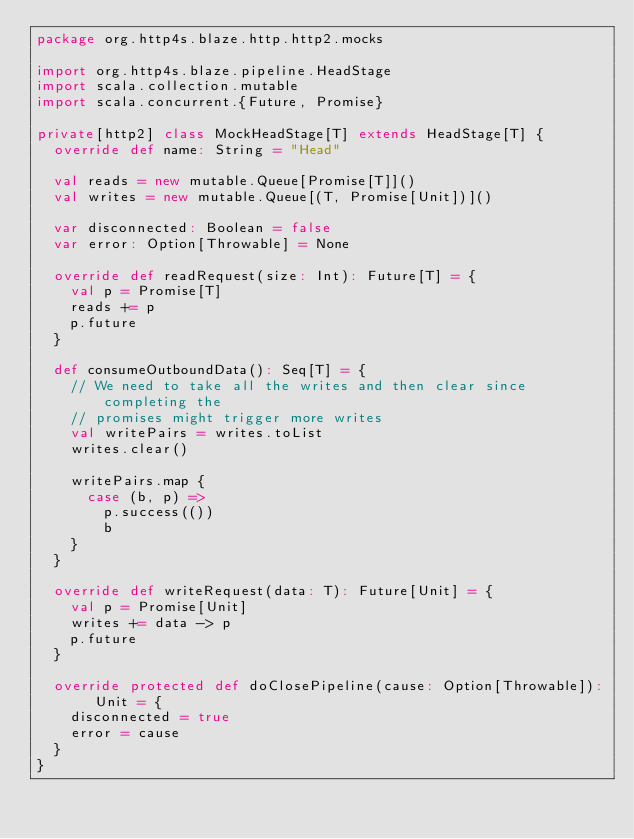Convert code to text. <code><loc_0><loc_0><loc_500><loc_500><_Scala_>package org.http4s.blaze.http.http2.mocks

import org.http4s.blaze.pipeline.HeadStage
import scala.collection.mutable
import scala.concurrent.{Future, Promise}

private[http2] class MockHeadStage[T] extends HeadStage[T] {
  override def name: String = "Head"

  val reads = new mutable.Queue[Promise[T]]()
  val writes = new mutable.Queue[(T, Promise[Unit])]()

  var disconnected: Boolean = false
  var error: Option[Throwable] = None

  override def readRequest(size: Int): Future[T] = {
    val p = Promise[T]
    reads += p
    p.future
  }

  def consumeOutboundData(): Seq[T] = {
    // We need to take all the writes and then clear since completing the
    // promises might trigger more writes
    val writePairs = writes.toList
    writes.clear()

    writePairs.map {
      case (b, p) =>
        p.success(())
        b
    }
  }

  override def writeRequest(data: T): Future[Unit] = {
    val p = Promise[Unit]
    writes += data -> p
    p.future
  }

  override protected def doClosePipeline(cause: Option[Throwable]): Unit = {
    disconnected = true
    error = cause
  }
}
</code> 